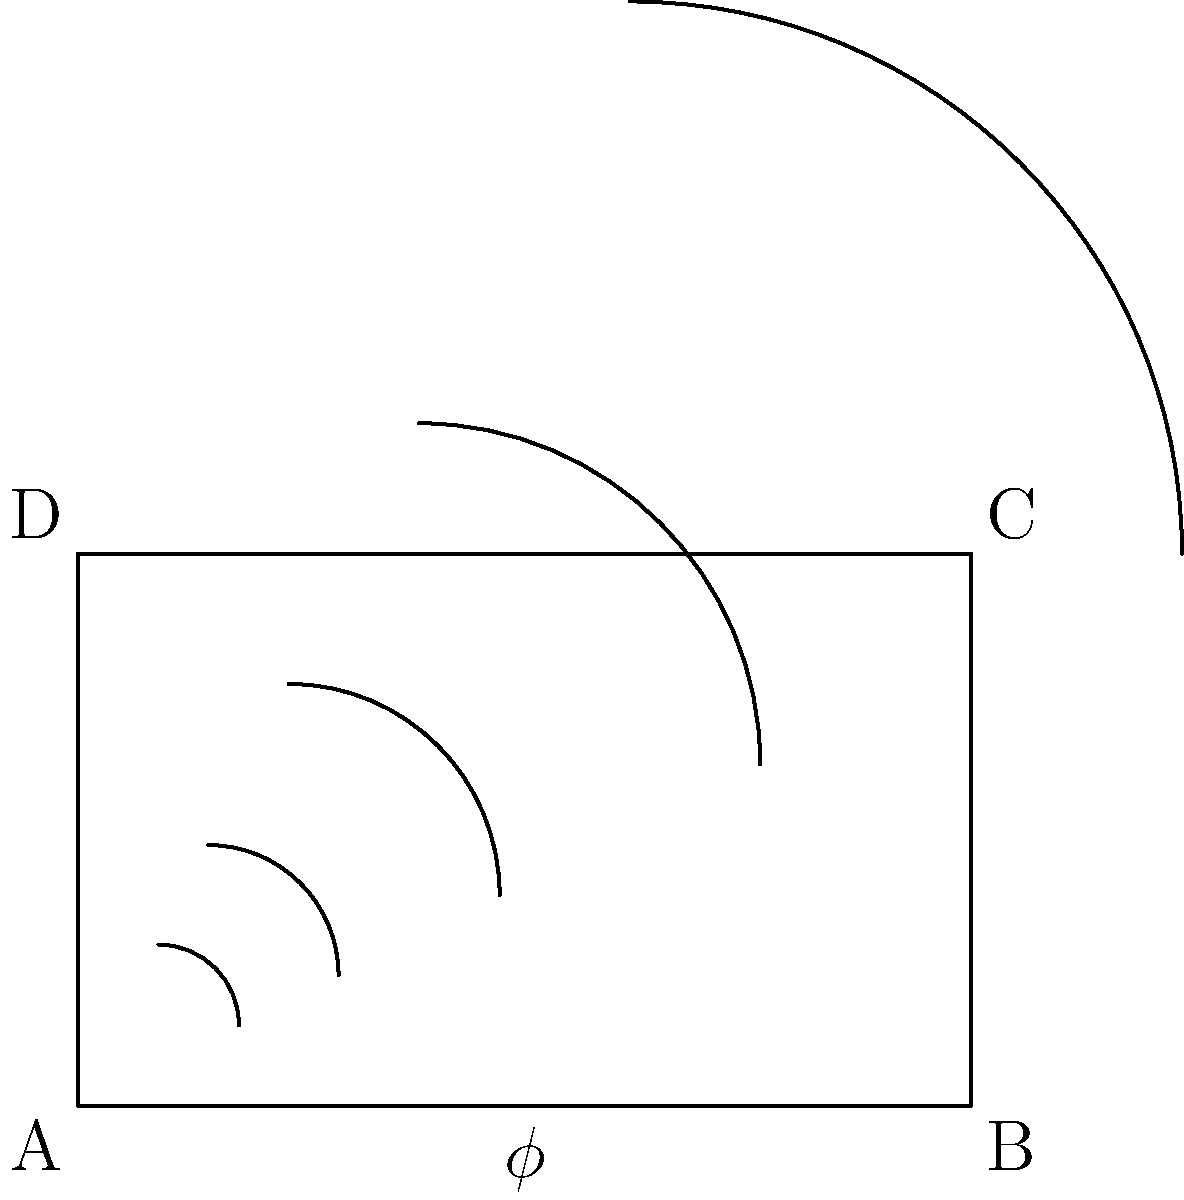In film composition, the golden ratio is often used to create visually appealing frames. The diagram shows a golden rectangle ABCD with a golden spiral inscribed within it. If the length of AB is 1.618 units, what is the length of AD, and how does this relate to the golden ratio ($\phi$)? To solve this problem, let's follow these steps:

1. Recall that the golden ratio, $\phi$, is approximately 1.618.

2. In a golden rectangle, the ratio of the longer side to the shorter side is equal to $\phi$.

3. We're given that AB = 1.618 units, which is the longer side of the rectangle.

4. To find AD (the shorter side), we can set up the following equation:
   $\frac{AB}{AD} = \phi$

5. Substituting the known values:
   $\frac{1.618}{AD} = 1.618$

6. Cross-multiply:
   $1.618 = 1.618 \times AD$

7. Solve for AD:
   $AD = \frac{1.618}{1.618} = 1$

8. Therefore, AD = 1 unit.

9. This demonstrates the golden ratio property:
   $\frac{AB}{AD} = \frac{1.618}{1} = 1.618 = \phi$

10. In film composition, this ratio can be used to create balanced and aesthetically pleasing frames. The golden spiral, formed by connecting quarter circles within squares of decreasing size (each new square's side length is the previous square's side length divided by $\phi$), can guide the placement of key elements in a shot.
Answer: AD = 1 unit; AB:AD = $\phi$:1 = 1.618:1 